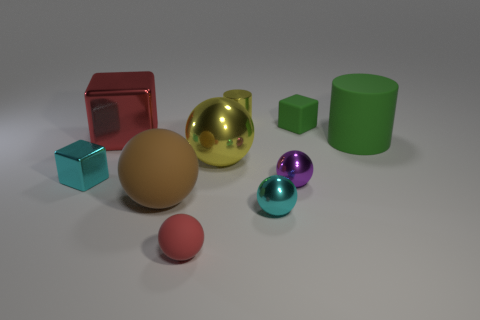What is the material of the tiny cyan object to the right of the tiny cyan object left of the red sphere?
Your answer should be compact. Metal. Is the green cube the same size as the yellow sphere?
Provide a succinct answer. No. How many things are either small objects that are to the right of the large brown sphere or tiny cyan blocks?
Offer a terse response. 6. What shape is the object in front of the small cyan object that is in front of the brown matte sphere?
Provide a short and direct response. Sphere. Does the yellow sphere have the same size as the cylinder right of the metal cylinder?
Give a very brief answer. Yes. What material is the tiny cyan thing that is in front of the small metal block?
Provide a succinct answer. Metal. How many green objects are to the left of the big green matte cylinder and in front of the large red block?
Provide a succinct answer. 0. There is a cyan block that is the same size as the red matte thing; what is it made of?
Make the answer very short. Metal. There is a metallic block that is behind the tiny shiny block; is it the same size as the cylinder right of the tiny metallic cylinder?
Keep it short and to the point. Yes. Are there any large yellow objects to the right of the big yellow object?
Offer a terse response. No. 